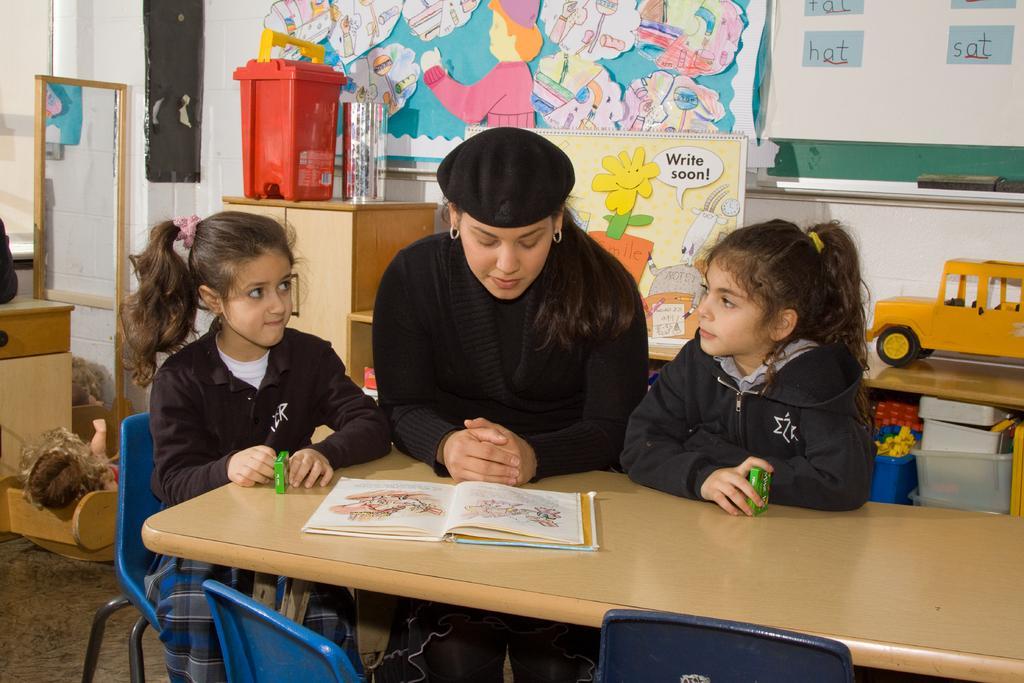How would you summarize this image in a sentence or two? As we can see in the image, there are three persons around the table. On table there is a book. These two girls are sitting on chairs. Behind them there is a poster, banner, basket, mirror and white color wall. 